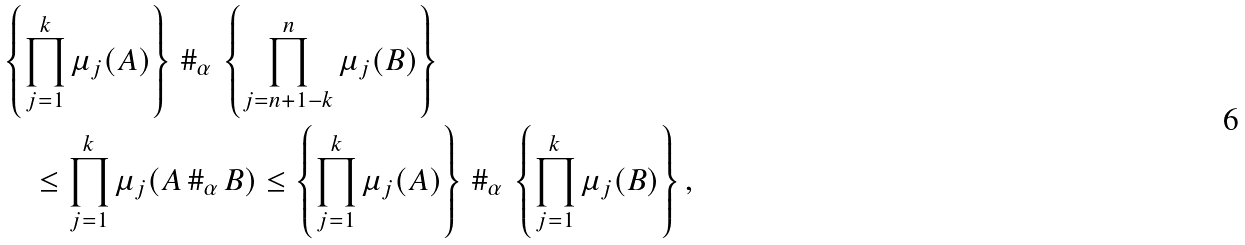<formula> <loc_0><loc_0><loc_500><loc_500>& \left \{ \prod _ { j = 1 } ^ { k } \mu _ { j } ( A ) \right \} \, \# _ { \alpha } \, \left \{ \prod _ { j = n + 1 - k } ^ { n } \mu _ { j } ( B ) \right \} \\ & \quad \leq \prod _ { j = 1 } ^ { k } \mu _ { j } ( A \, \# _ { \alpha } \, B ) \leq \left \{ \prod _ { j = 1 } ^ { k } \mu _ { j } ( A ) \right \} \, \# _ { \alpha } \, \left \{ \prod _ { j = 1 } ^ { k } \mu _ { j } ( B ) \right \} ,</formula> 